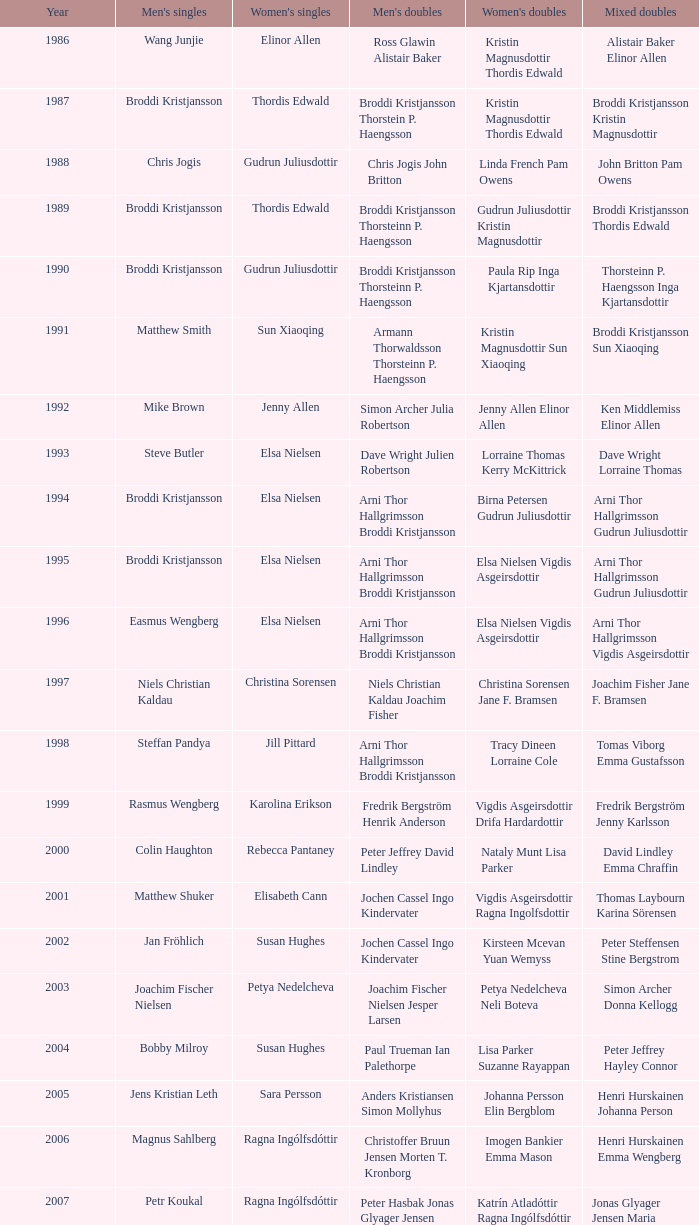In which mixed doubles did niels christian kaldau participate in men's singles? Joachim Fisher Jane F. Bramsen. 